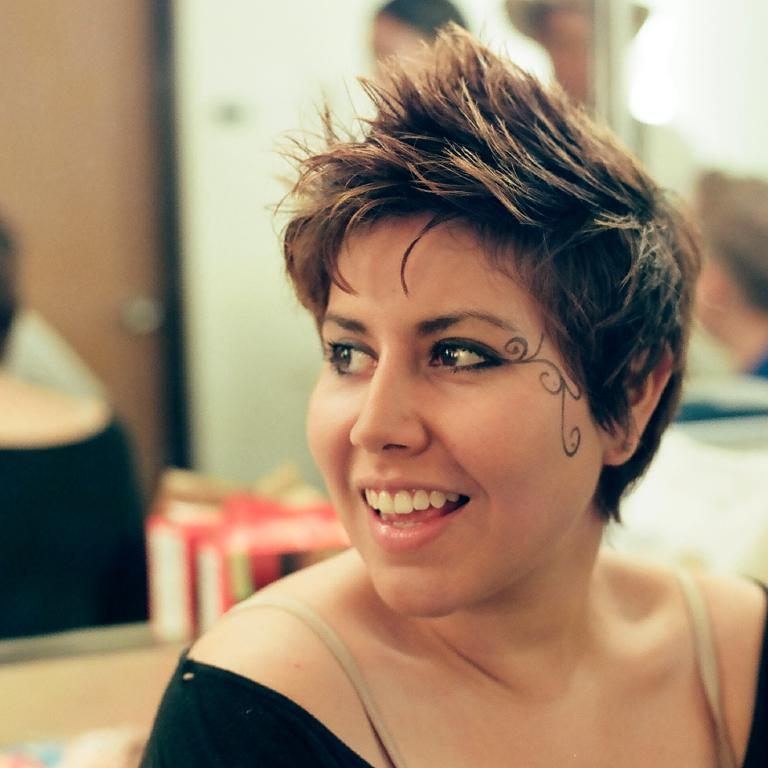Who is present in the image? There is a woman in the image. What is the woman doing in the image? The woman is sitting and smiling. What is the woman wearing in the image? The woman is wearing a black shirt. What can be seen in the background of the image? There is a mirror, a door, and people in the backdrop of the image. What is the net weight of the impulse in the image? There is no net or impulse present in the image; it features a woman sitting and smiling, with a background that includes a mirror, door, and people. 